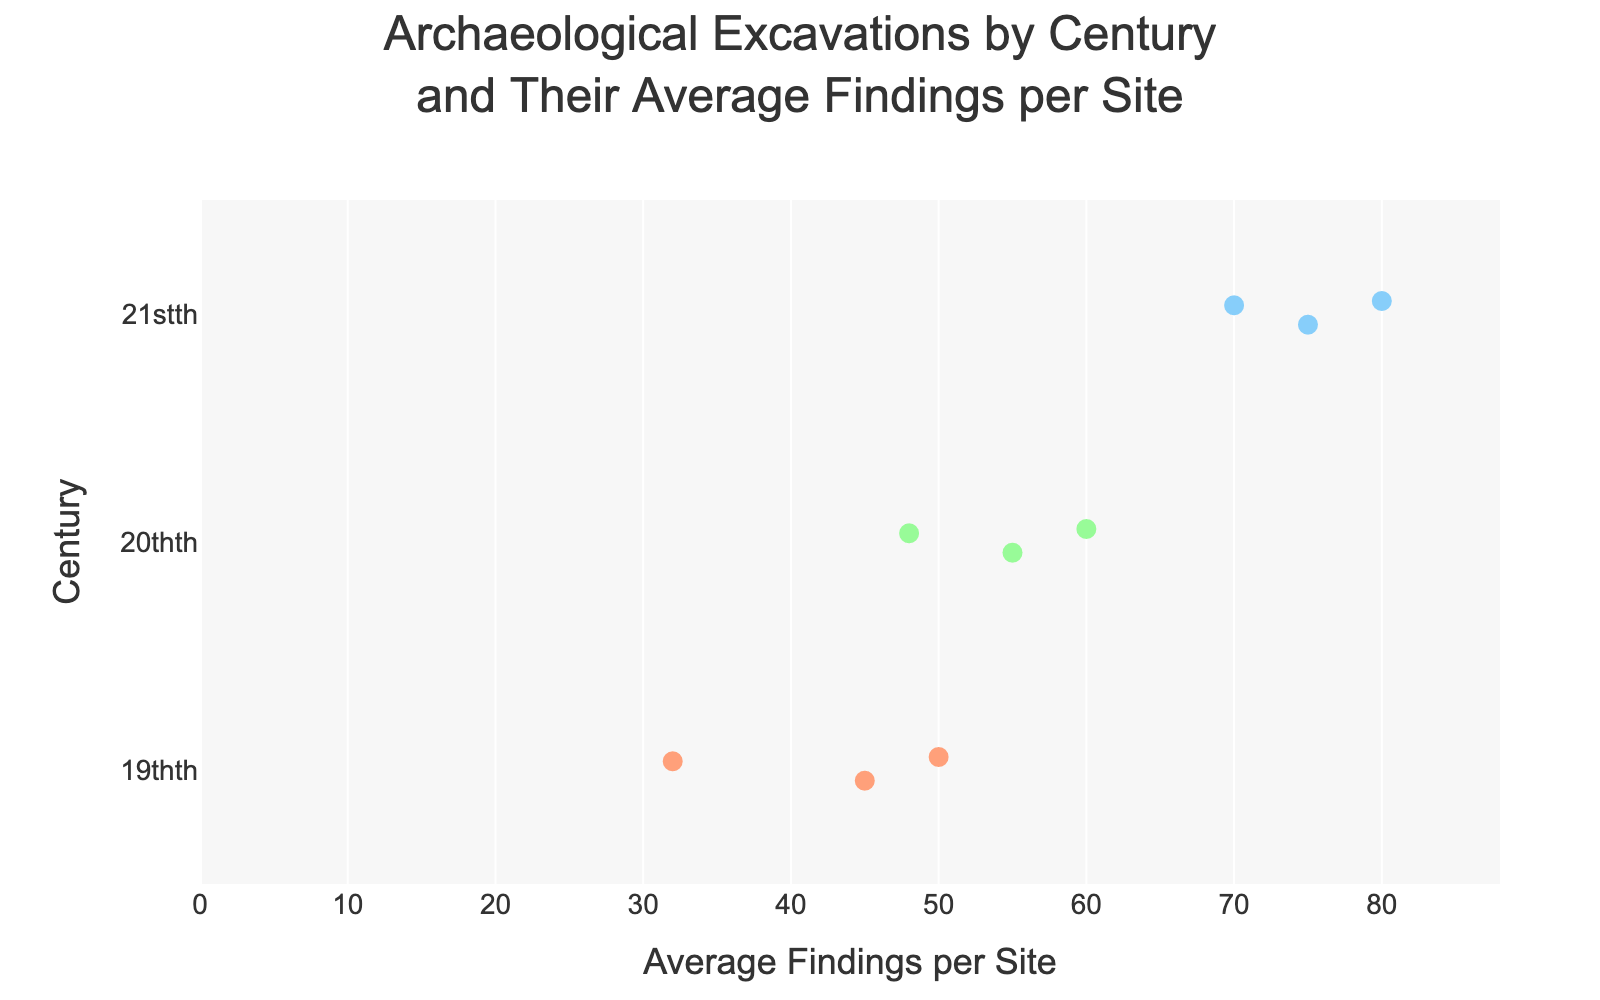How many centuries are represented in the plot? By looking at the y-axis with the labeled centuries, we can see there are three: 19th, 20th, and 21st.
Answer: 3 What is the average number of findings for the site with the highest average in the 21st century? The plot shows that Gobekli Tepe in Turkey has the highest average findings in the 21st century, which is 80.
Answer: 80 Which century has the highest range of average findings? Observing the spread of the dots along the x-axis, we see that the 21st century has the widest range, from 70 to 80 findings.
Answer: 21st What is the total average number of findings for all sites in the 20th century? Sum all the average findings for the sites in the 20th century: Jericho (60) + Ugarit (55) + Khirbet Qumran (48) = 163.
Answer: 163 Compare the average findings of the sites in the 19th century to those in the 20th century. Which century has a higher average? Calculate the average for each century. For the 19th century: (45 + 32 + 50) / 3 = 42.33. For the 20th century: (60 + 55 + 48) / 3 = 54.33. Thus, the 20th century has a higher average.
Answer: 20th century Which century has the least variation in average findings among its sites? Look at the spread of the points. The 19th century shows the least variation, with findings ranging from 32 to 50.
Answer: 19th Which archaeological site has the lowest average findings, and in which century is it? By looking at the lowest point on the x-axis, we see that Persepolis in Iran from the 19th century has the lowest average findings of 32.
Answer: Persepolis, 19th How many sites are represented in the 21st century? Count the number of dots showing sites for the 21st century: Petra, Gobekli Tepe, and Hattusa – a total of 3.
Answer: 3 Which century has the greatest difference between the highest and lowest average findings among its sites? Calculate the differences: For the 19th century: 50 - 32 = 18; for the 20th century: 60 - 48 = 12; for the 21st century: 80 - 70 = 10. The 19th century has the greatest difference.
Answer: 19th century 